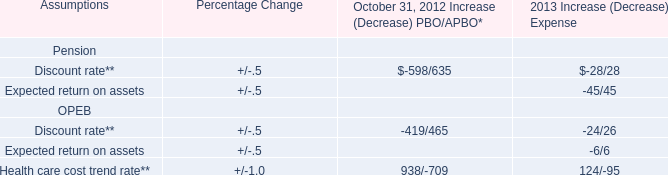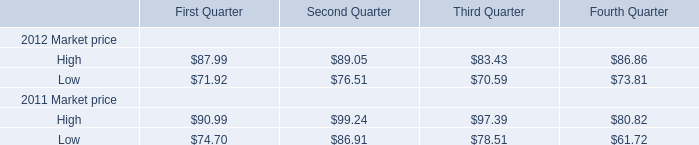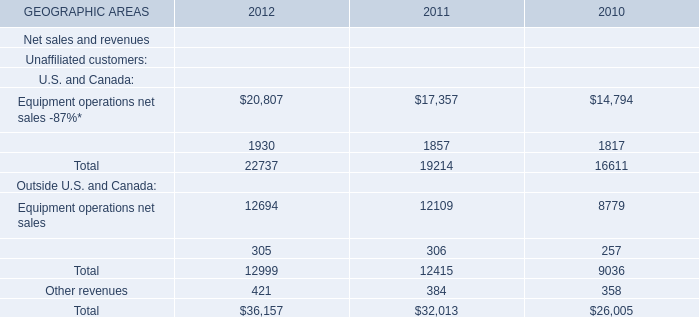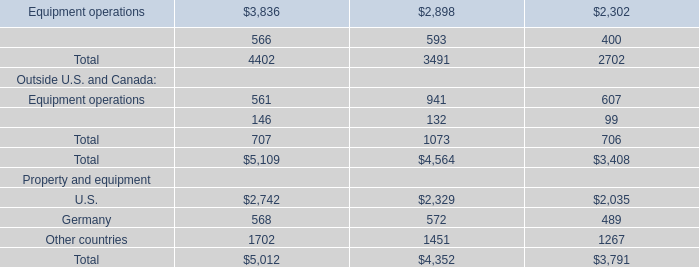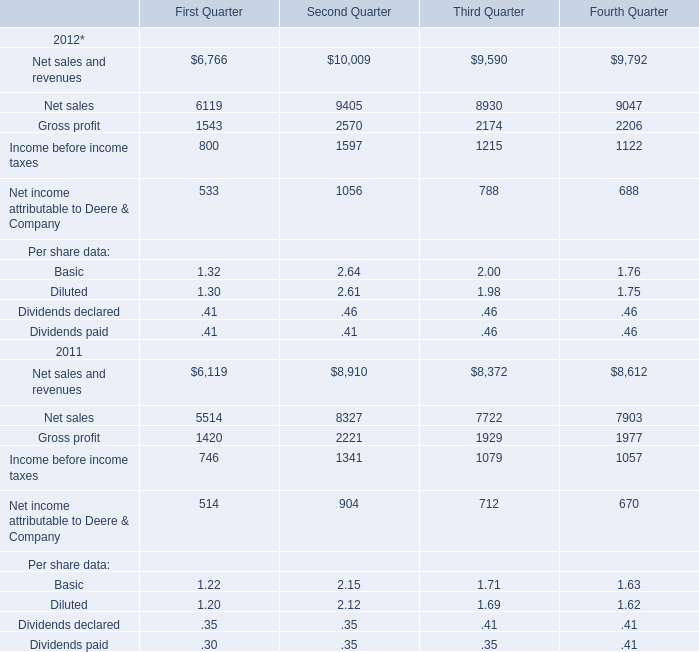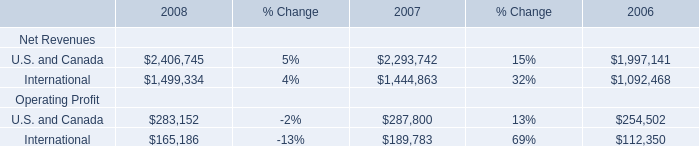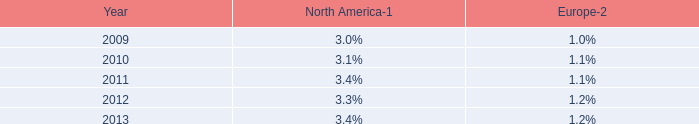What do all High Market price sum up without those High Market price smaller than 85, in 2012? 
Computations: ((87.99 + 89.05) + 86.86)
Answer: 263.9. 